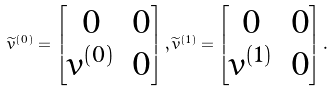<formula> <loc_0><loc_0><loc_500><loc_500>\widetilde { v } ^ { ( 0 ) } = \begin{bmatrix} 0 & 0 \\ v ^ { ( 0 ) } & 0 \end{bmatrix} , \widetilde { v } ^ { ( 1 ) } = \begin{bmatrix} 0 & 0 \\ v ^ { ( 1 ) } & 0 \end{bmatrix} .</formula> 